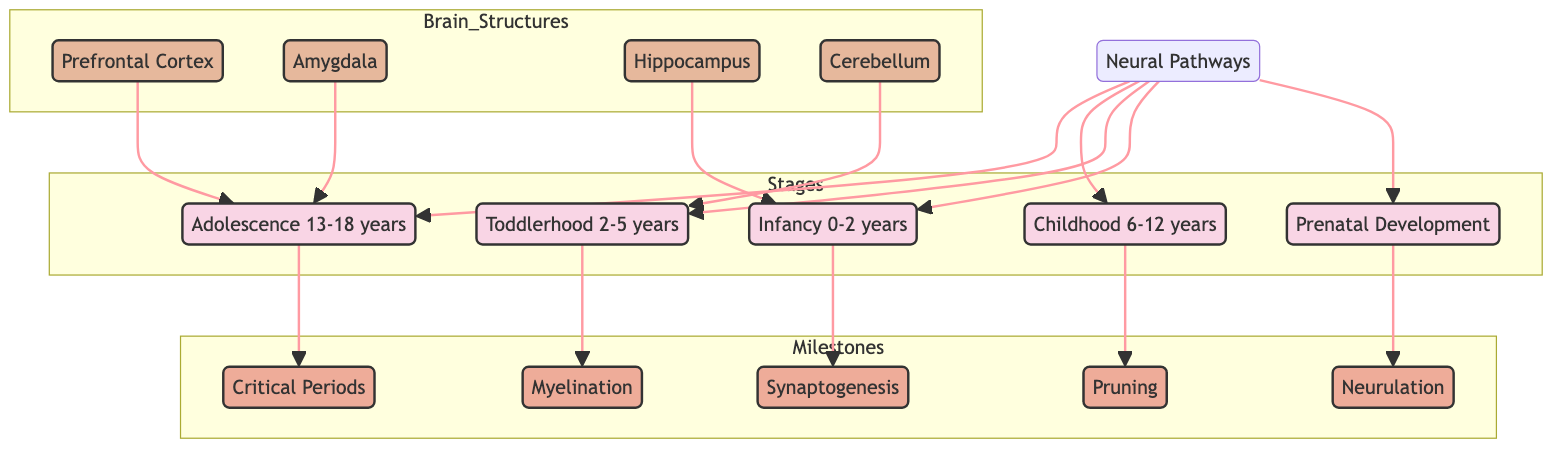What is the first milestone in brain development? The diagram lists 'Neurulation' as the first milestone connected to the 'Prenatal Development' stage, indicating that this is the initial step in brain development.
Answer: Neurulation Which brain structure is linked to infancy? The diagram shows that the 'Hippocampus' is directly connected to the 'Infancy (0-2 years)' stage, indicating its relevance during that time.
Answer: Hippocampus How many brain structures are depicted in the diagram? Counting the nodes in the 'Brain Structures' subgraph reveals four key structures: Prefrontal Cortex, Amygdala, Hippocampus, and Cerebellum.
Answer: Four Which stage relates to the 'Prefrontal Cortex'? The diagram indicates that the 'Prefrontal Cortex' is associated with 'Adolescence', as it is connected to that stage.
Answer: Adolescence During which stage does synaptogenesis occur? The diagram specifies that 'Synaptogenesis' happens during the 'Infancy (0-2 years)' stage, showing the timing of this milestone.
Answer: Infancy What is the last neurodevelopmental milestone shown in the diagram? The last milestone is 'Critical Periods', which is linked to the 'Adolescence (13-18 years)' stage according to the flow of the diagram.
Answer: Critical Periods Which milestone is associated with toddlerhood? The diagram connects 'Myelination' with 'Toddlerhood (2-5 years)', indicating this developmental process occurs during that stage.
Answer: Myelination How are neural pathways related to prenatal development? The diagram shows that 'Neural Pathways' connect to 'Prenatal Development', suggesting that pathway connectivity begins early in development.
Answer: Connection Which brain structure is emphasized for motor skills development? The diagram indicates that the 'Cerebellum', which is connected to 'Toddlerhood', plays a significant role in motor skills development during that stage.
Answer: Cerebellum 